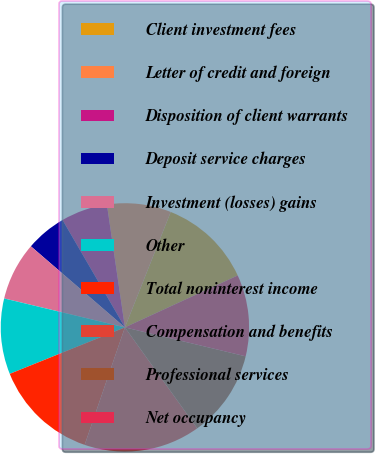<chart> <loc_0><loc_0><loc_500><loc_500><pie_chart><fcel>Client investment fees<fcel>Letter of credit and foreign<fcel>Disposition of client warrants<fcel>Deposit service charges<fcel>Investment (losses) gains<fcel>Other<fcel>Total noninterest income<fcel>Compensation and benefits<fcel>Professional services<fcel>Net occupancy<nl><fcel>12.12%<fcel>8.33%<fcel>6.06%<fcel>5.3%<fcel>7.58%<fcel>9.85%<fcel>13.64%<fcel>15.15%<fcel>11.36%<fcel>10.61%<nl></chart> 